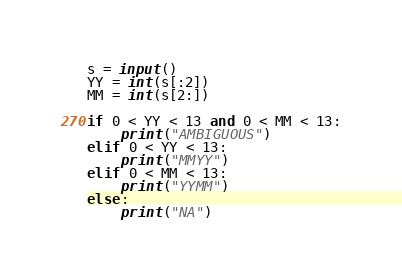<code> <loc_0><loc_0><loc_500><loc_500><_Python_>s = input()
YY = int(s[:2]) 
MM = int(s[2:])

if 0 < YY < 13 and 0 < MM < 13:
    print("AMBIGUOUS")
elif 0 < YY < 13:
    print("MMYY")
elif 0 < MM < 13:
    print("YYMM")
else:
    print("NA")</code> 